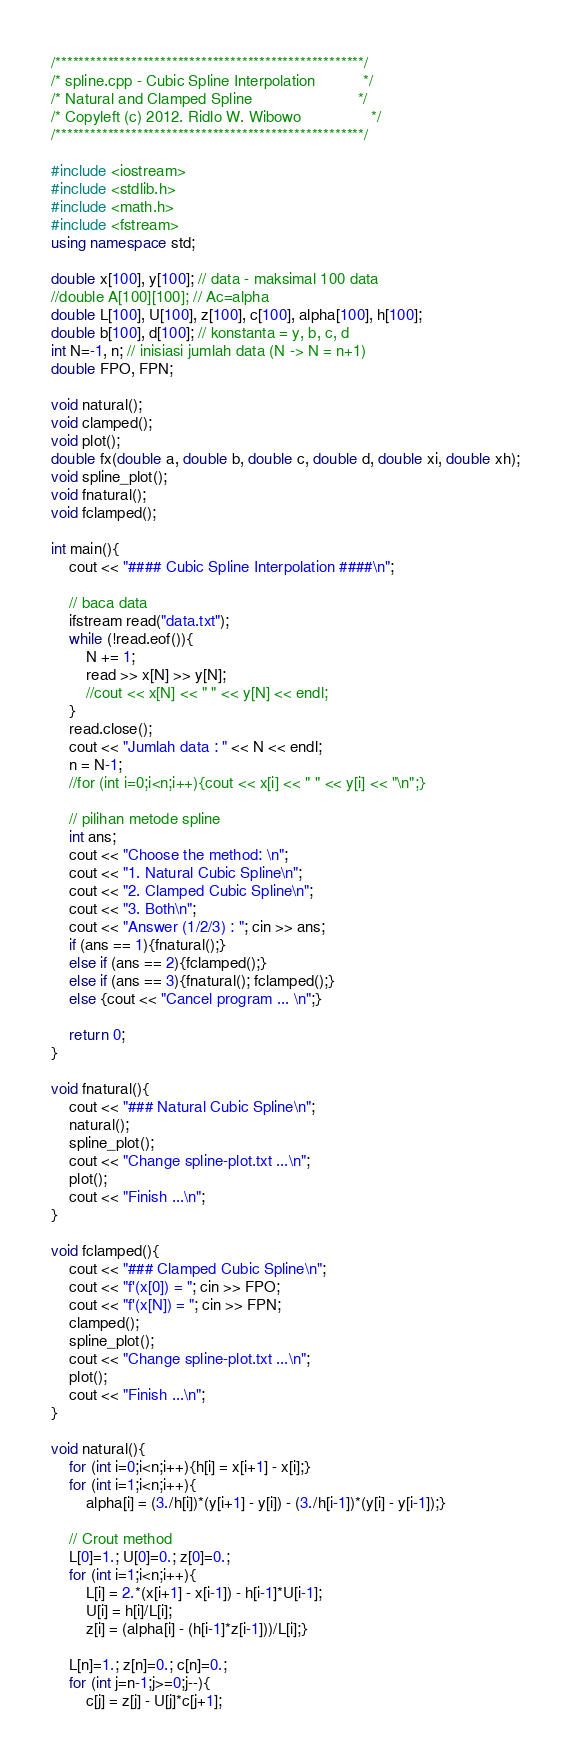Convert code to text. <code><loc_0><loc_0><loc_500><loc_500><_C++_>/*****************************************************/
/* spline.cpp - Cubic Spline Interpolation           */
/* Natural and Clamped Spline                        */
/* Copyleft (c) 2012. Ridlo W. Wibowo                */
/*****************************************************/

#include <iostream>
#include <stdlib.h>
#include <math.h>
#include <fstream>
using namespace std;

double x[100], y[100]; // data - maksimal 100 data
//double A[100][100]; // Ac=alpha
double L[100], U[100], z[100], c[100], alpha[100], h[100];
double b[100], d[100]; // konstanta = y, b, c, d
int N=-1, n; // inisiasi jumlah data (N -> N = n+1)
double FPO, FPN;

void natural();
void clamped();
void plot();
double fx(double a, double b, double c, double d, double xi, double xh);
void spline_plot();
void fnatural();
void fclamped();

int main(){ 
    cout << "#### Cubic Spline Interpolation ####\n";

    // baca data
    ifstream read("data.txt");
    while (!read.eof()){
        N += 1;
        read >> x[N] >> y[N];
        //cout << x[N] << " " << y[N] << endl; 
    }
    read.close();
    cout << "Jumlah data : " << N << endl;
    n = N-1;
    //for (int i=0;i<n;i++){cout << x[i] << " " << y[i] << "\n";}
        
    // pilihan metode spline
    int ans;
    cout << "Choose the method: \n";
    cout << "1. Natural Cubic Spline\n";
    cout << "2. Clamped Cubic Spline\n";
    cout << "3. Both\n";
    cout << "Answer (1/2/3) : "; cin >> ans;
    if (ans == 1){fnatural();}
    else if (ans == 2){fclamped();}
    else if (ans == 3){fnatural(); fclamped();}
    else {cout << "Cancel program ... \n";}

    return 0;
}

void fnatural(){
    cout << "### Natural Cubic Spline\n";
    natural(); 
    spline_plot(); 
    cout << "Change spline-plot.txt ...\n";
    plot();
    cout << "Finish ...\n";
}

void fclamped(){
    cout << "### Clamped Cubic Spline\n";
    cout << "f'(x[0]) = "; cin >> FPO;
    cout << "f'(x[N]) = "; cin >> FPN;
    clamped(); 
    spline_plot();
    cout << "Change spline-plot.txt ...\n";
    plot();
    cout << "Finish ...\n";
}

void natural(){
    for (int i=0;i<n;i++){h[i] = x[i+1] - x[i];}
    for (int i=1;i<n;i++){
        alpha[i] = (3./h[i])*(y[i+1] - y[i]) - (3./h[i-1])*(y[i] - y[i-1]);}
    
    // Crout method
    L[0]=1.; U[0]=0.; z[0]=0.;
    for (int i=1;i<n;i++){
        L[i] = 2.*(x[i+1] - x[i-1]) - h[i-1]*U[i-1];
        U[i] = h[i]/L[i];
        z[i] = (alpha[i] - (h[i-1]*z[i-1]))/L[i];}
    
    L[n]=1.; z[n]=0.; c[n]=0.;
    for (int j=n-1;j>=0;j--){
        c[j] = z[j] - U[j]*c[j+1];</code> 